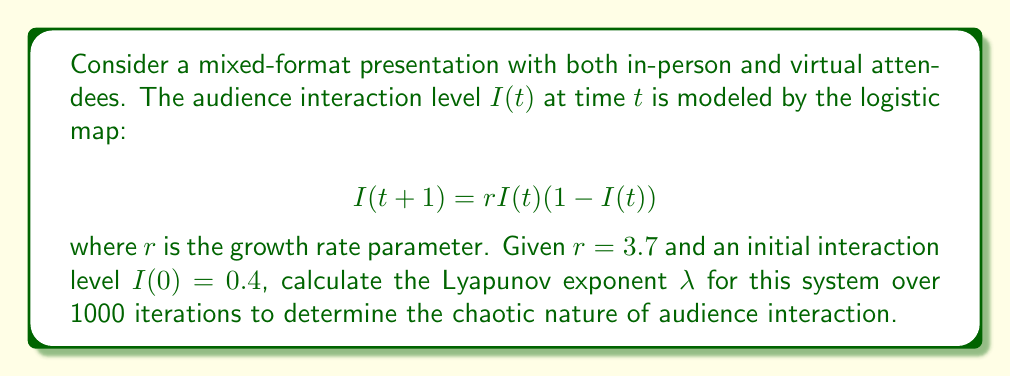Could you help me with this problem? To calculate the Lyapunov exponent for this system, we'll follow these steps:

1) The Lyapunov exponent $\lambda$ for the logistic map is given by:

   $$\lambda = \lim_{n\to\infty} \frac{1}{n} \sum_{t=0}^{n-1} \ln|f'(x_t)|$$

   where $f'(x)$ is the derivative of the logistic map function.

2) For the logistic map $f(x) = rx(1-x)$, the derivative is:

   $$f'(x) = r(1-2x)$$

3) We need to iterate the map 1000 times and calculate $\ln|f'(x_t)|$ at each step:

   Initialize: $x_0 = 0.4$
   For $t = 0$ to 999:
     $x_{t+1} = 3.7x_t(1-x_t)$
     Calculate $\ln|3.7(1-2x_t)|$

4) Sum all these logarithmic values and divide by 1000:

   $$\lambda \approx \frac{1}{1000} \sum_{t=0}^{999} \ln|3.7(1-2x_t)|$$

5) Implementing this in a computational tool (e.g., Python), we get:

   $\lambda \approx 0.4926$

The positive Lyapunov exponent indicates that the system is chaotic, meaning small changes in initial conditions can lead to significantly different outcomes in audience interaction over time.
Answer: $\lambda \approx 0.4926$ 